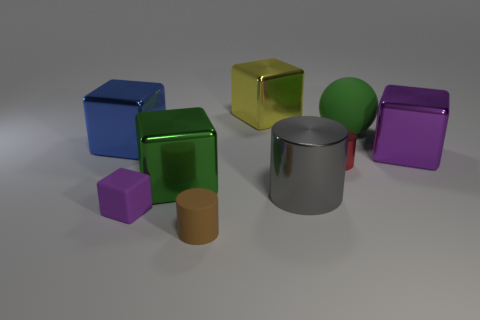The gray thing that is made of the same material as the yellow block is what size?
Keep it short and to the point. Large. Are there any other metallic spheres of the same color as the sphere?
Keep it short and to the point. No. What number of things are blocks behind the large green rubber thing or big yellow things?
Give a very brief answer. 1. Does the large green block have the same material as the cylinder that is in front of the tiny purple object?
Keep it short and to the point. No. There is a object that is the same color as the sphere; what size is it?
Offer a very short reply. Large. Is there a yellow thing made of the same material as the brown object?
Offer a terse response. No. How many objects are either metallic objects on the left side of the big green block or matte things that are right of the small brown thing?
Make the answer very short. 2. There is a blue thing; is it the same shape as the large object that is behind the large ball?
Your response must be concise. Yes. What number of other objects are there of the same shape as the green metallic thing?
Keep it short and to the point. 4. What number of objects are either purple matte things or green matte spheres?
Provide a succinct answer. 2. 